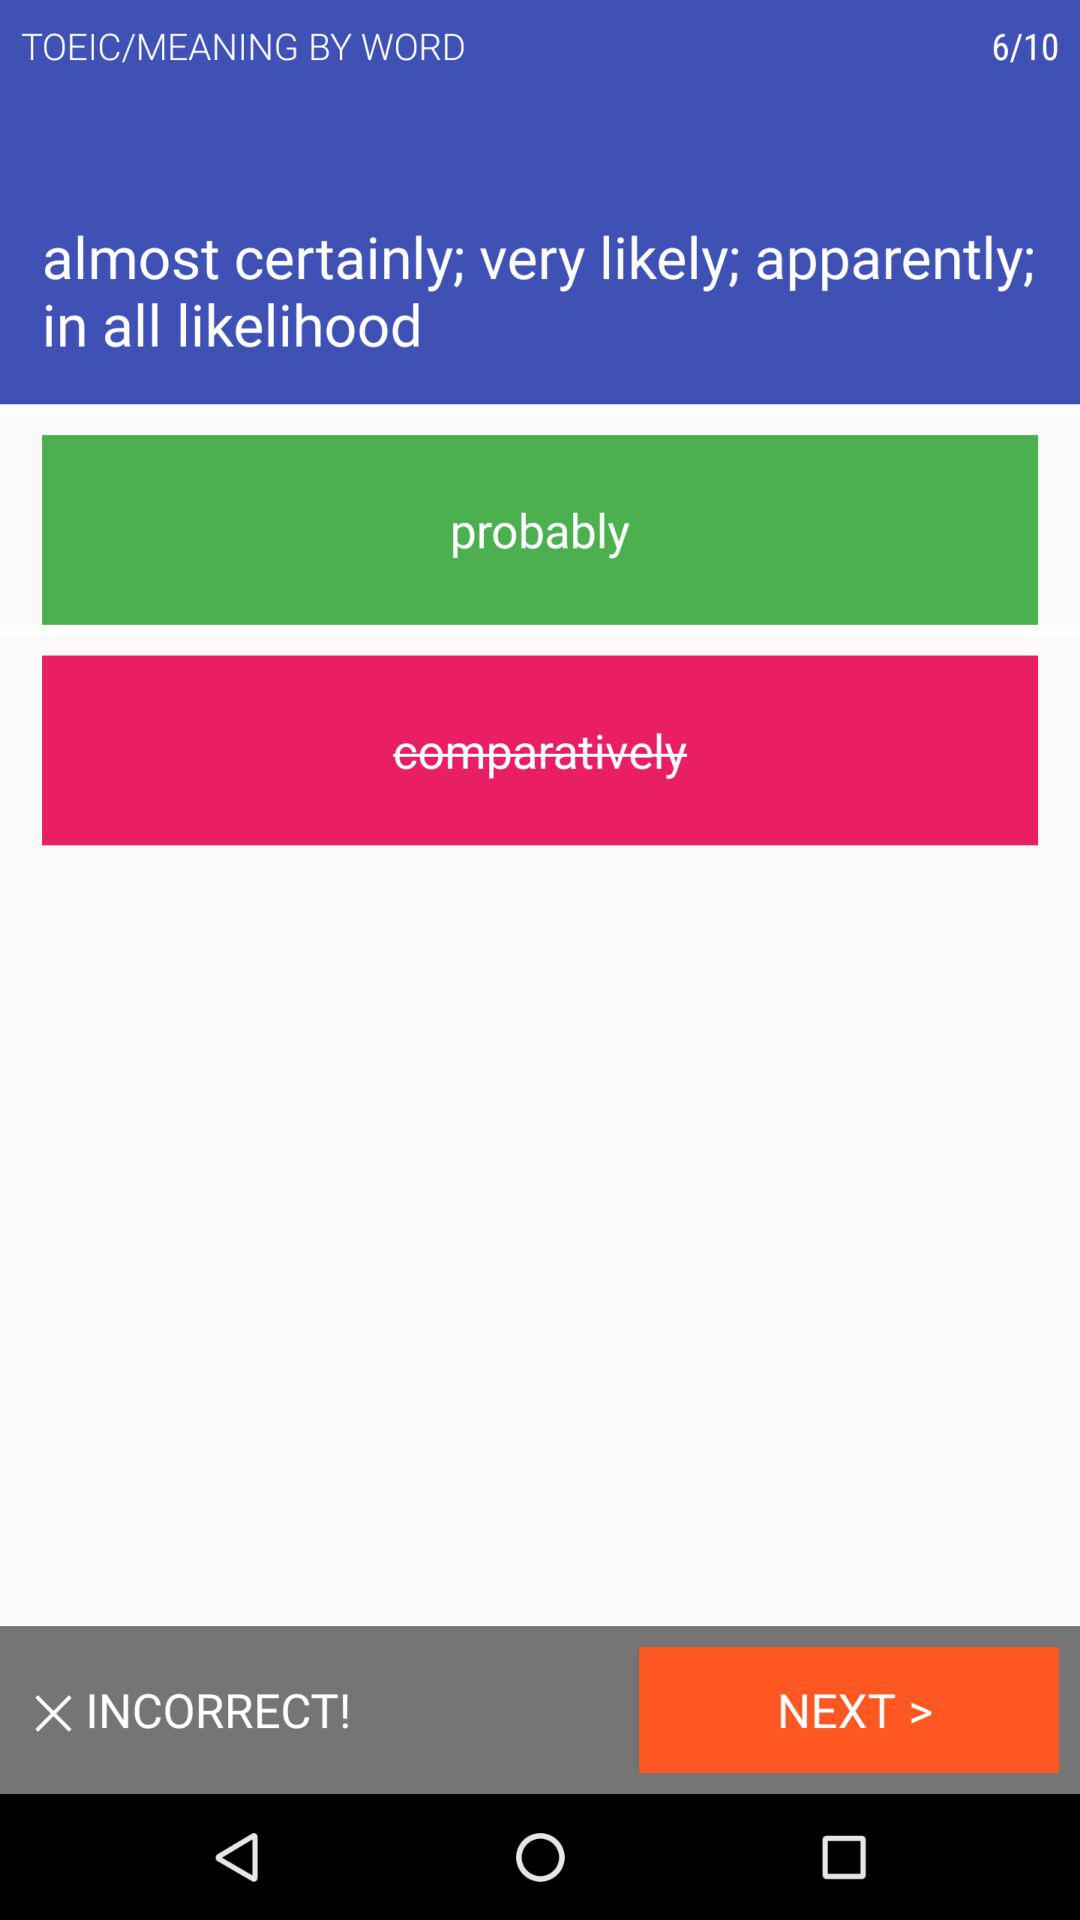How many questions in total are there? There are a total of 10 questions. 